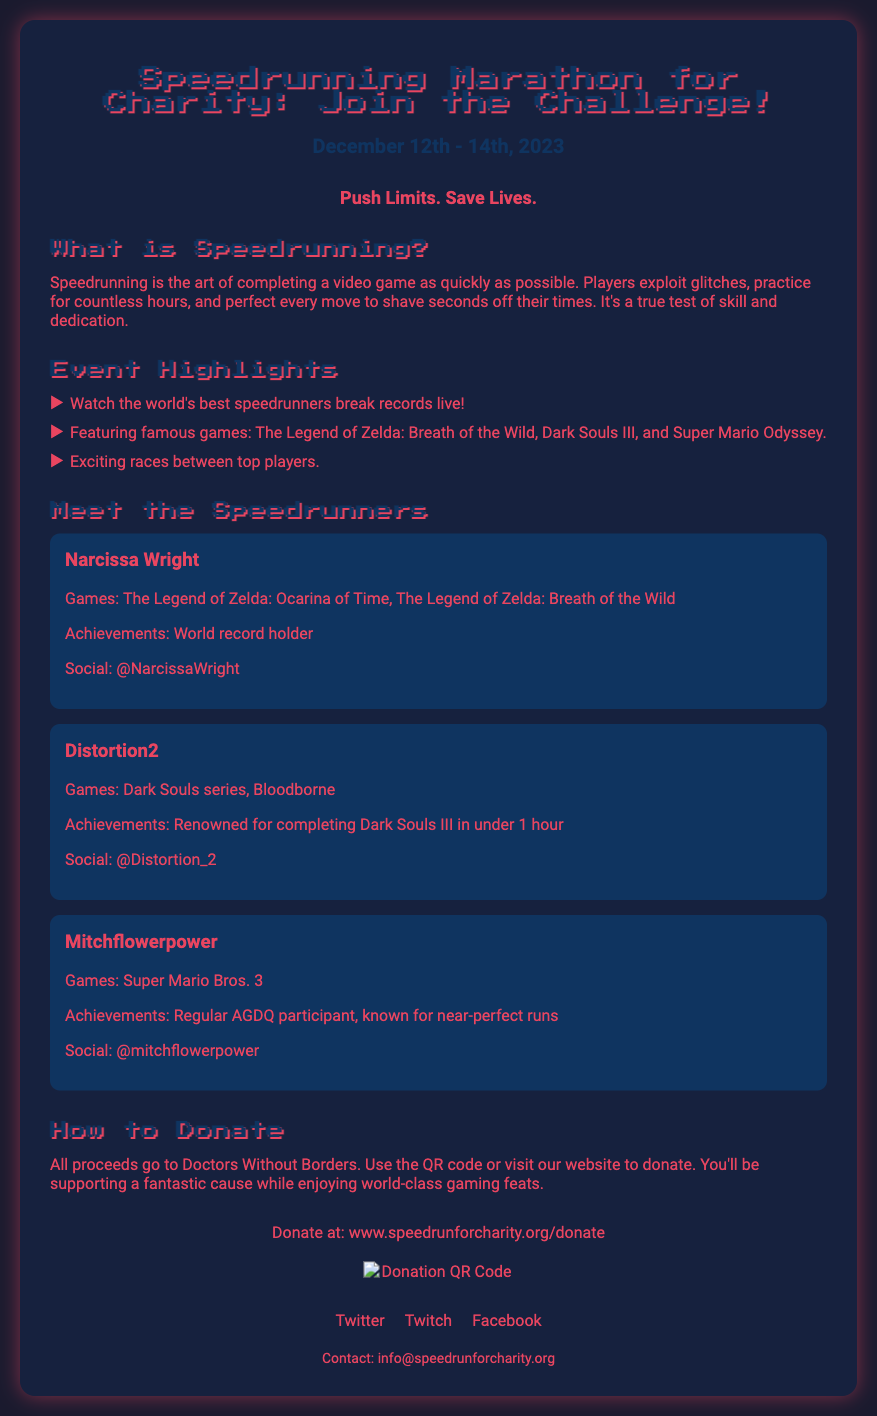What are the event dates? The event dates are specified in the document under "event-date."
Answer: December 12th - 14th, 2023 Who is a world record holder? The document lists Narcissa Wright as a world record holder under "Meet the Speedrunners."
Answer: Narcissa Wright How many players have exciting races? The document states that there are multiple top players racing in the event under "Event Highlights."
Answer: multiple What is the charity supported by the event? The document mentions the charity in the "How to Donate" section.
Answer: Doctors Without Borders Which game is Mitchflowerpower known for? The document lists games under "Meet the Speedrunners" for each speedrunner.
Answer: Super Mario Bros. 3 What is the social media handle for Distortion2? The social media handle is mentioned in the description of Distortion2 in the document.
Answer: @Distortion_2 What is the tagline of the event? The tagline is stated prominently in the document under "tagline."
Answer: Push Limits. Save Lives Where can you donate? The donation website is specified in the "How to Donate" section of the document.
Answer: www.speedrunforcharity.org/donate 